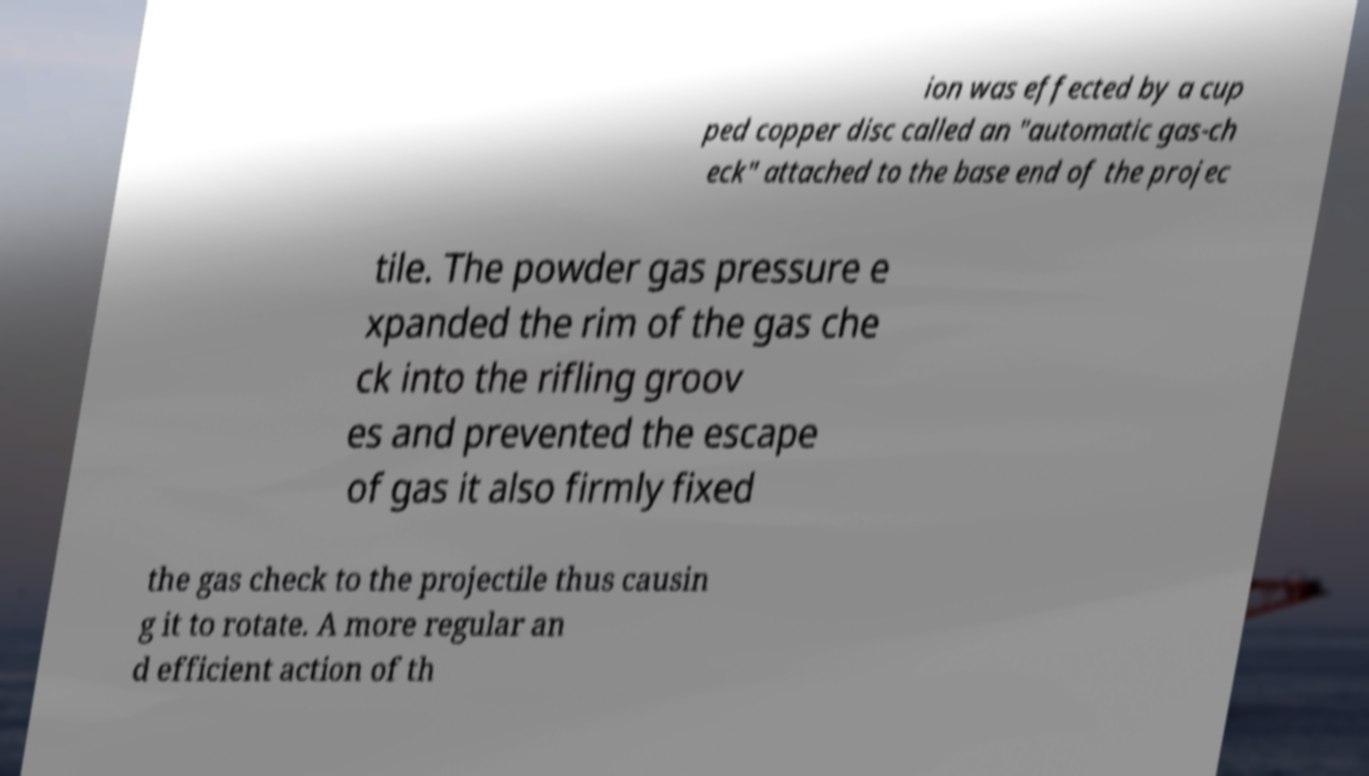Could you extract and type out the text from this image? ion was effected by a cup ped copper disc called an "automatic gas-ch eck" attached to the base end of the projec tile. The powder gas pressure e xpanded the rim of the gas che ck into the rifling groov es and prevented the escape of gas it also firmly fixed the gas check to the projectile thus causin g it to rotate. A more regular an d efficient action of th 